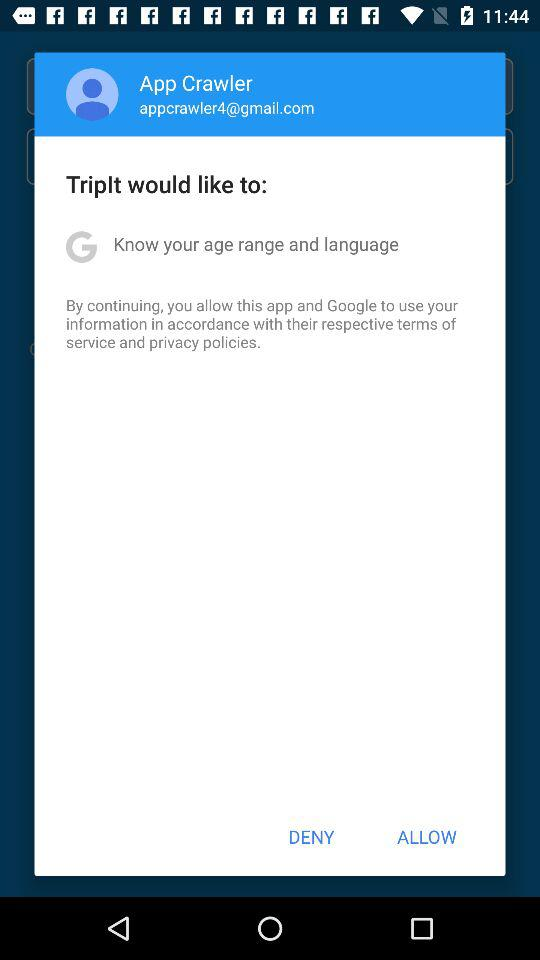What is the email address? The email address is appcrawler4@gmail.com. 